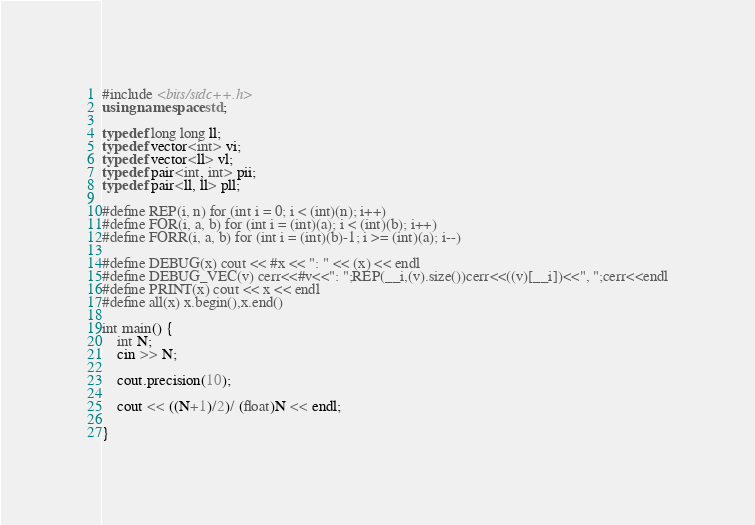Convert code to text. <code><loc_0><loc_0><loc_500><loc_500><_C++_>#include <bits/stdc++.h>
using namespace std;

typedef long long ll;
typedef vector<int> vi;
typedef vector<ll> vl;
typedef pair<int, int> pii;
typedef pair<ll, ll> pll;

#define REP(i, n) for (int i = 0; i < (int)(n); i++)
#define FOR(i, a, b) for (int i = (int)(a); i < (int)(b); i++)
#define FORR(i, a, b) for (int i = (int)(b)-1; i >= (int)(a); i--)

#define DEBUG(x) cout << #x << ": " << (x) << endl
#define DEBUG_VEC(v) cerr<<#v<<": ";REP(__i,(v).size())cerr<<((v)[__i])<<", ";cerr<<endl
#define PRINT(x) cout << x << endl
#define all(x) x.begin(),x.end()

int main() {
    int N;
    cin >> N;

    cout.precision(10);

    cout << ((N+1)/2)/ (float)N << endl;

}

</code> 